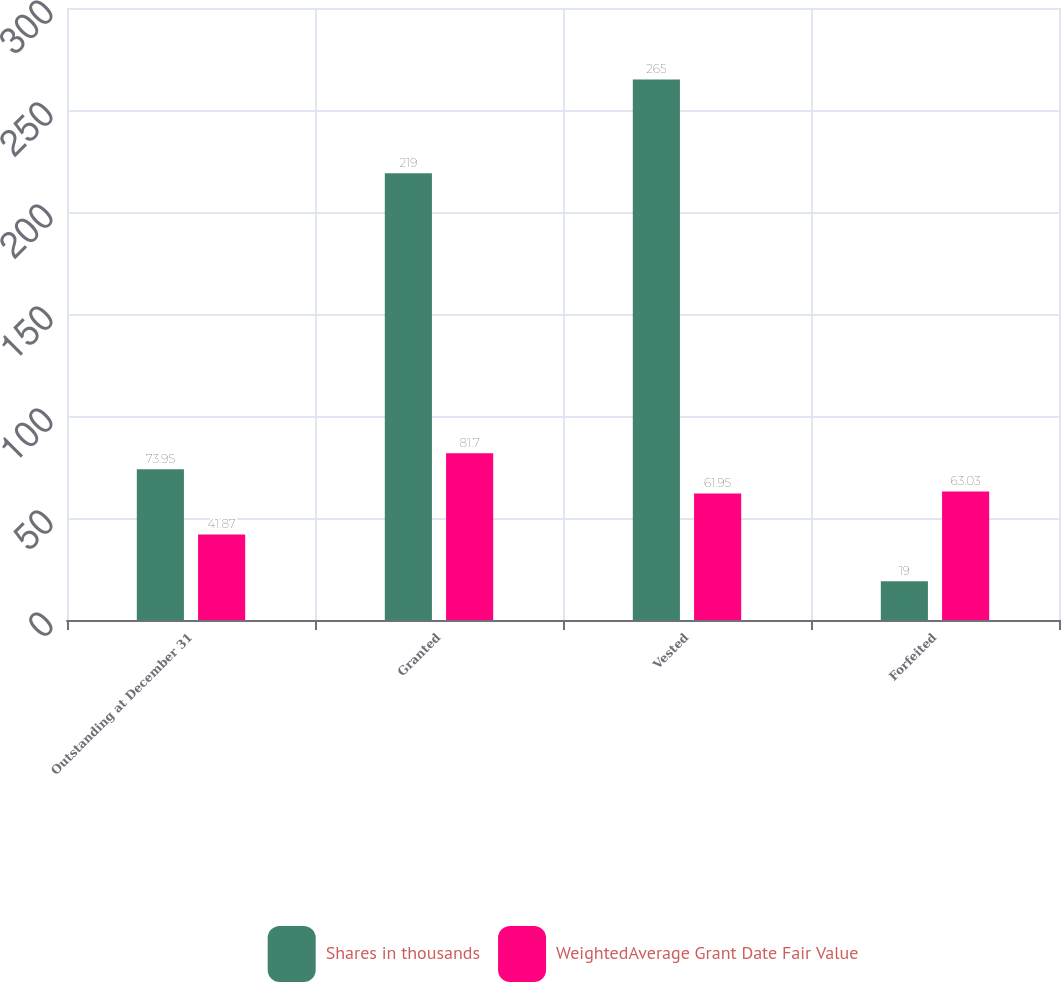Convert chart. <chart><loc_0><loc_0><loc_500><loc_500><stacked_bar_chart><ecel><fcel>Outstanding at December 31<fcel>Granted<fcel>Vested<fcel>Forfeited<nl><fcel>Shares in thousands<fcel>73.95<fcel>219<fcel>265<fcel>19<nl><fcel>WeightedAverage Grant Date Fair Value<fcel>41.87<fcel>81.7<fcel>61.95<fcel>63.03<nl></chart> 